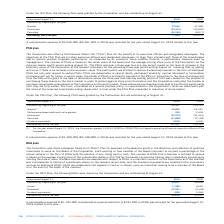According to Cogeco's financial document, What are the objectives of the PSU plans? The objectives of the PSU Plan are to retain executive officers and designated employees, to align their interests with those of the shareholders and to sustain positive corporate performance, as measured by an economic value creation formula, a performance measure used by management.. The document states: "f its executive officers and designated employees. The objectives of the PSU Plan are to retain executive officers and designated employees, to align ..." Also, How is the number of PSUs calculated? The number of PSUs is based on the dollar value of the award and the average closing stock price of the Corporation for the previous twelve month period ending August 31.. The document states: "formula, a performance measure used by management. The number of PSUs is based on the dollar value of the award and the average closing stock price of..." Also, How many PSUs were granted for the year ended August 31, 2019? According to the financial document, 14,625. The relevant text states: "ar ended August 31, 2019, the Corporation granted 14,625 (19,025 in 2018) PSUs to Cogeco's executive officers as executive officers of the Corporation...." Also, can you calculate: What is the increase / (decrease) in the granted from 2018 to 2019? Based on the calculation: 45,800 - 65,525, the result is -19725. This is based on the information: "Granted (1) 45,800 65,525 Granted (1) 45,800 65,525..." The key data points involved are: 45,800, 65,525. Also, can you calculate: What is the average Performance-based additional units granted from 2018 to 2019? To answer this question, I need to perform calculations using the financial data. The calculation is: (200 + 2,639) / 2, which equals 1419.5. This is based on the information: "Performance-based additional units granted 200 2,639 Performance-based additional units granted 200 2,639..." The key data points involved are: 2,639, 200. Also, can you calculate: What is the average distributed from 2018 to 2019? To answer this question, I need to perform calculations using the financial data. The calculation is: -(43,319 + 41,441) / 2, which equals -42380. This is based on the information: "Distributed (43,319) (41,441) Distributed (43,319) (41,441)..." The key data points involved are: 41,441, 43,319. 